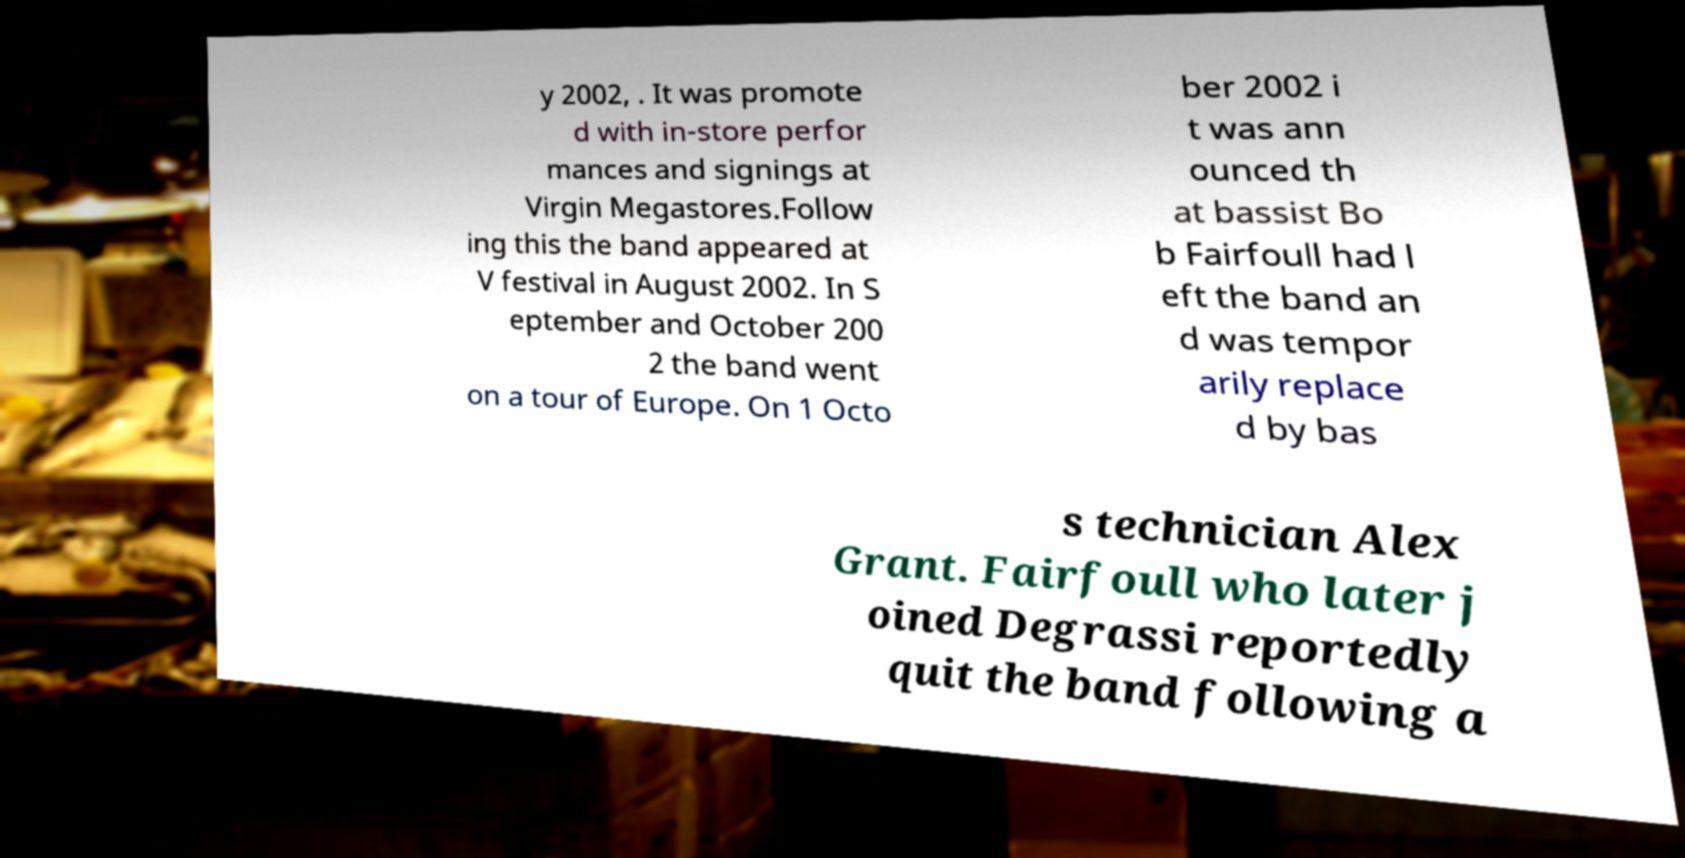Please identify and transcribe the text found in this image. y 2002, . It was promote d with in-store perfor mances and signings at Virgin Megastores.Follow ing this the band appeared at V festival in August 2002. In S eptember and October 200 2 the band went on a tour of Europe. On 1 Octo ber 2002 i t was ann ounced th at bassist Bo b Fairfoull had l eft the band an d was tempor arily replace d by bas s technician Alex Grant. Fairfoull who later j oined Degrassi reportedly quit the band following a 